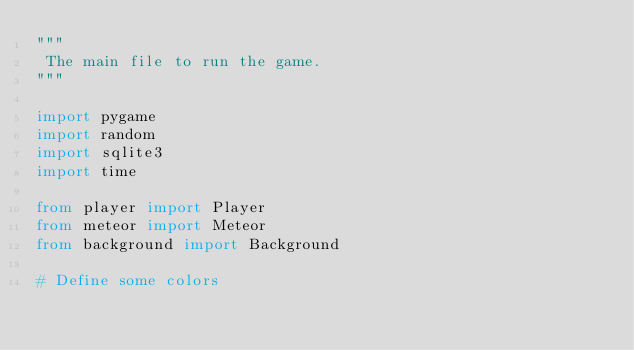<code> <loc_0><loc_0><loc_500><loc_500><_Python_>"""
 The main file to run the game.
"""

import pygame
import random
import sqlite3
import time

from player import Player
from meteor import Meteor
from background import Background

# Define some colors</code> 